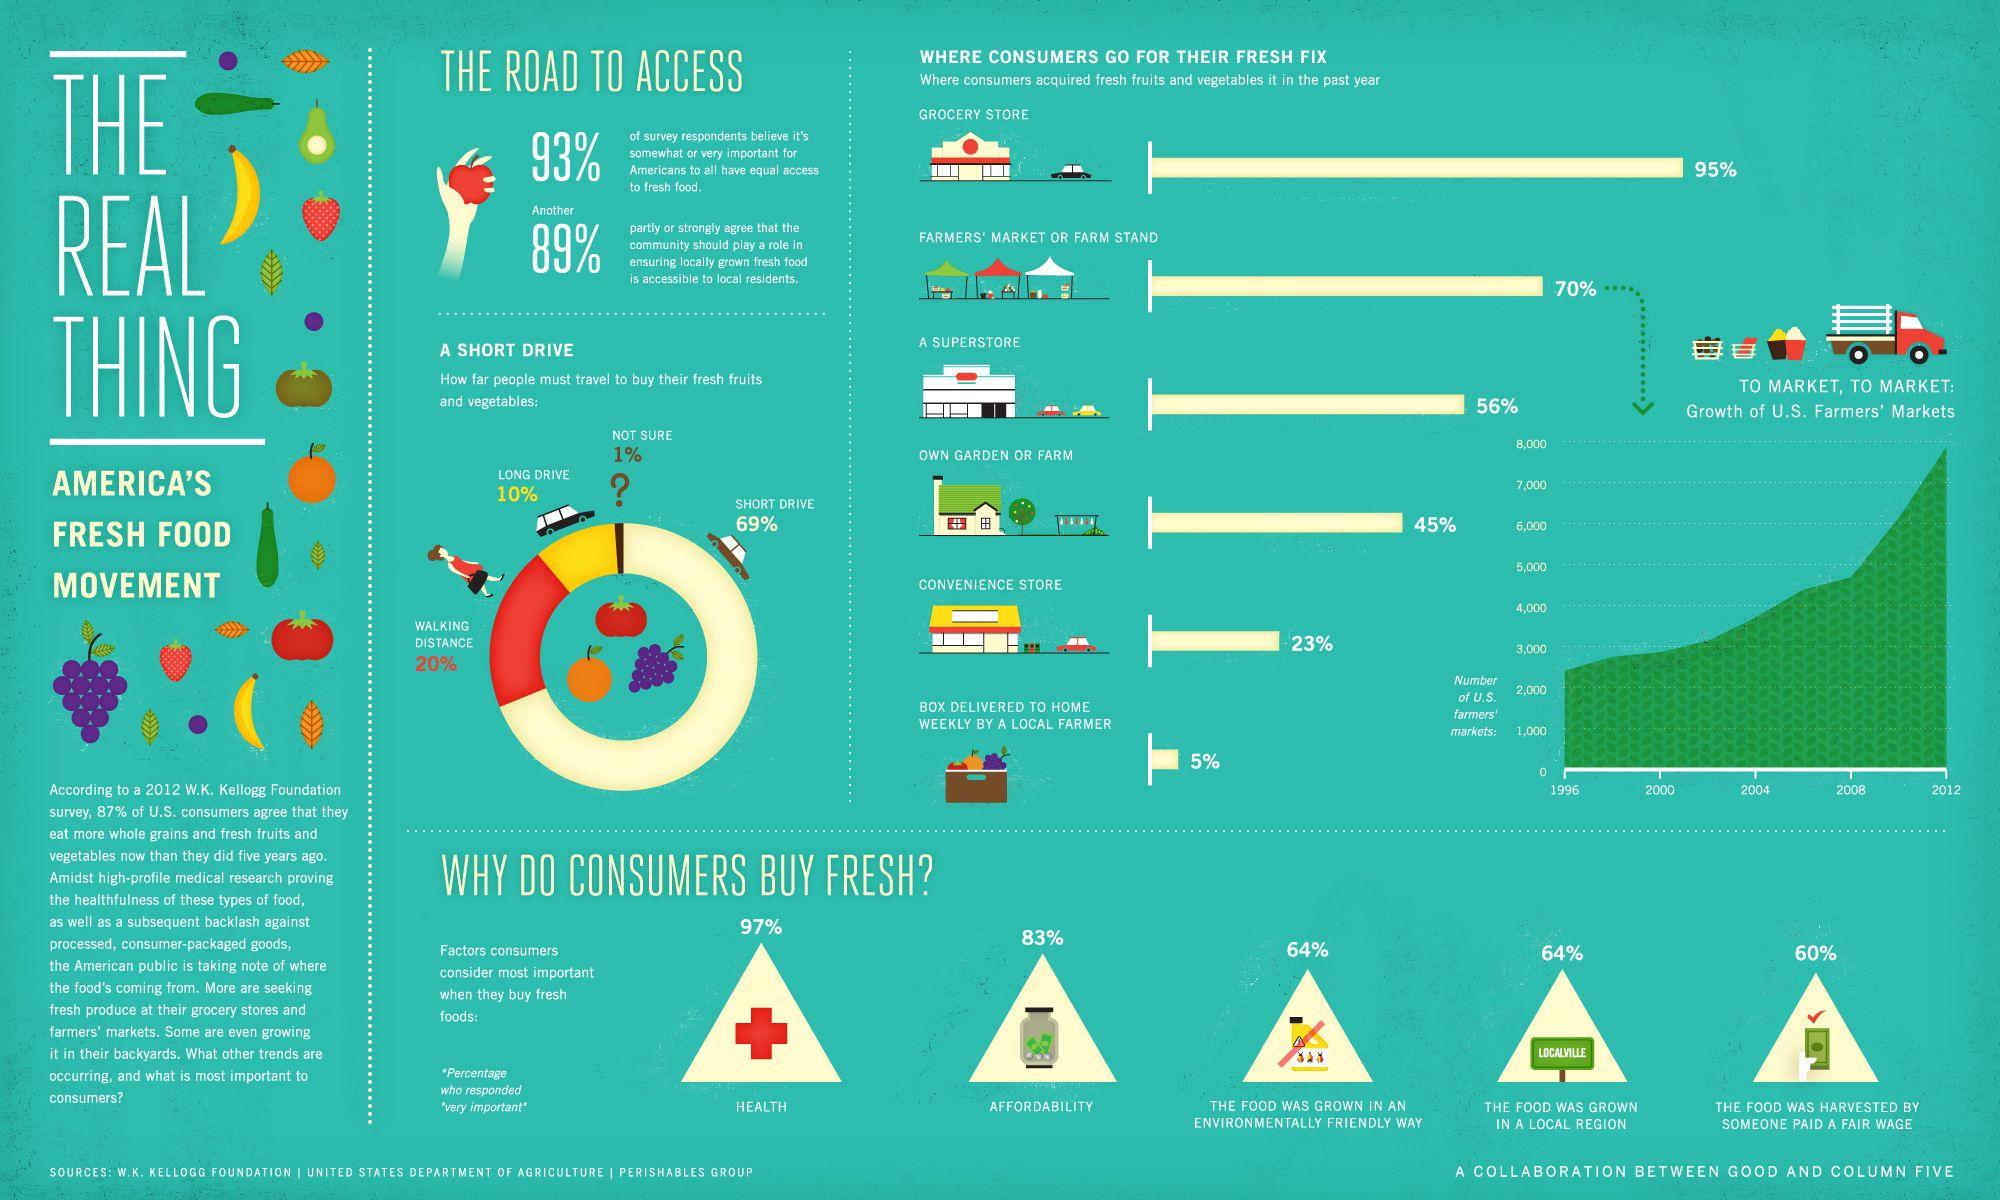Draw attention to some important aspects in this diagram. The second largest source from which consumers can obtain fresh fruits and vegetables is either a farmers' market or a farm stand. According to a recent survey, a significant percentage of Americans do not believe that the community needs to take action to ensure access to fresh food for all members. Specifically, 11% of respondents indicated that they do not believe this to be the case. According to recent data, 45% of Americans are planting fruits and vegetables in their homes. Of all the places where consumers purchase fresh fruits and vegetables, the second least popular choice is convenience stores, with a relatively low percentage of consumers opting to buy their produce from these retailers. It is estimated that approximately 7% of Americans do not believe that having access to fresh food is important for them. 